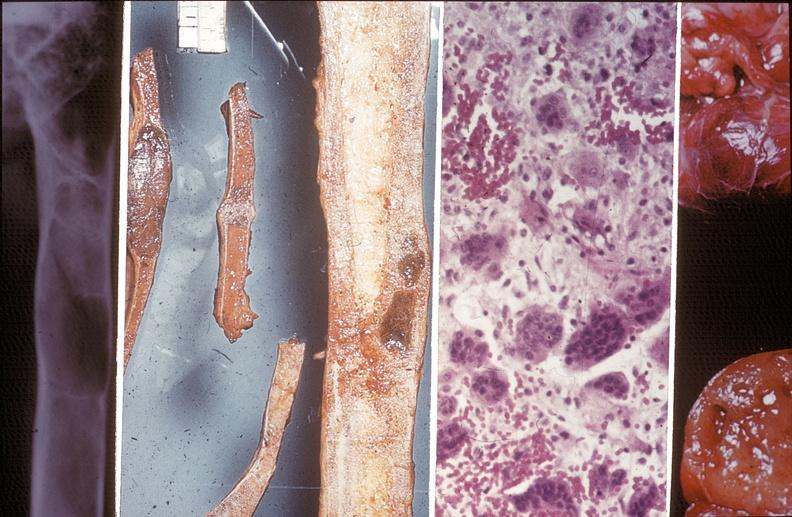s joints present?
Answer the question using a single word or phrase. Yes 